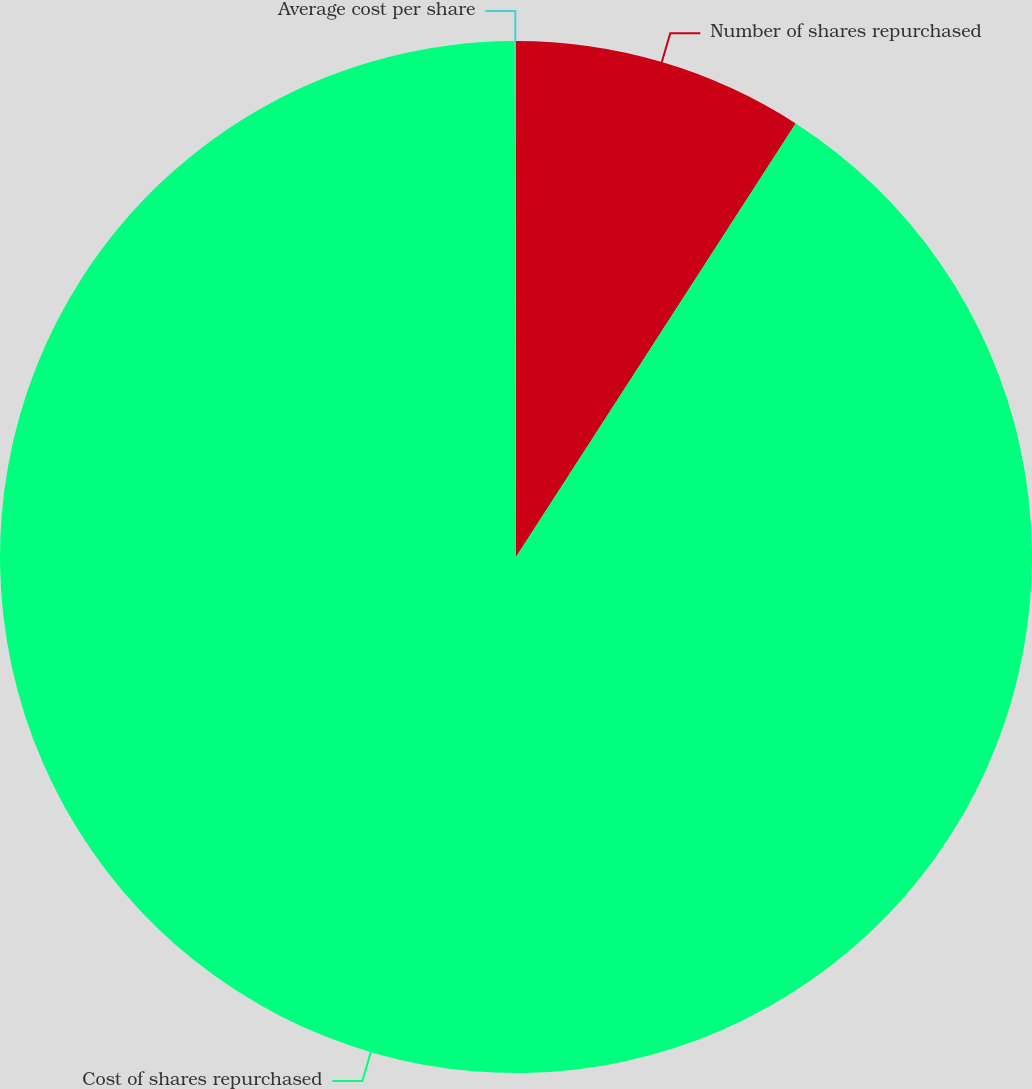Convert chart to OTSL. <chart><loc_0><loc_0><loc_500><loc_500><pie_chart><fcel>Number of shares repurchased<fcel>Cost of shares repurchased<fcel>Average cost per share<nl><fcel>9.12%<fcel>90.85%<fcel>0.04%<nl></chart> 